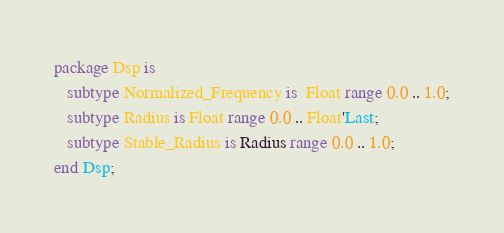<code> <loc_0><loc_0><loc_500><loc_500><_Ada_>package Dsp is
   subtype Normalized_Frequency is  Float range 0.0 .. 1.0;
   subtype Radius is Float range 0.0 .. Float'Last;
   subtype Stable_Radius is Radius range 0.0 .. 1.0;
end Dsp;
</code> 